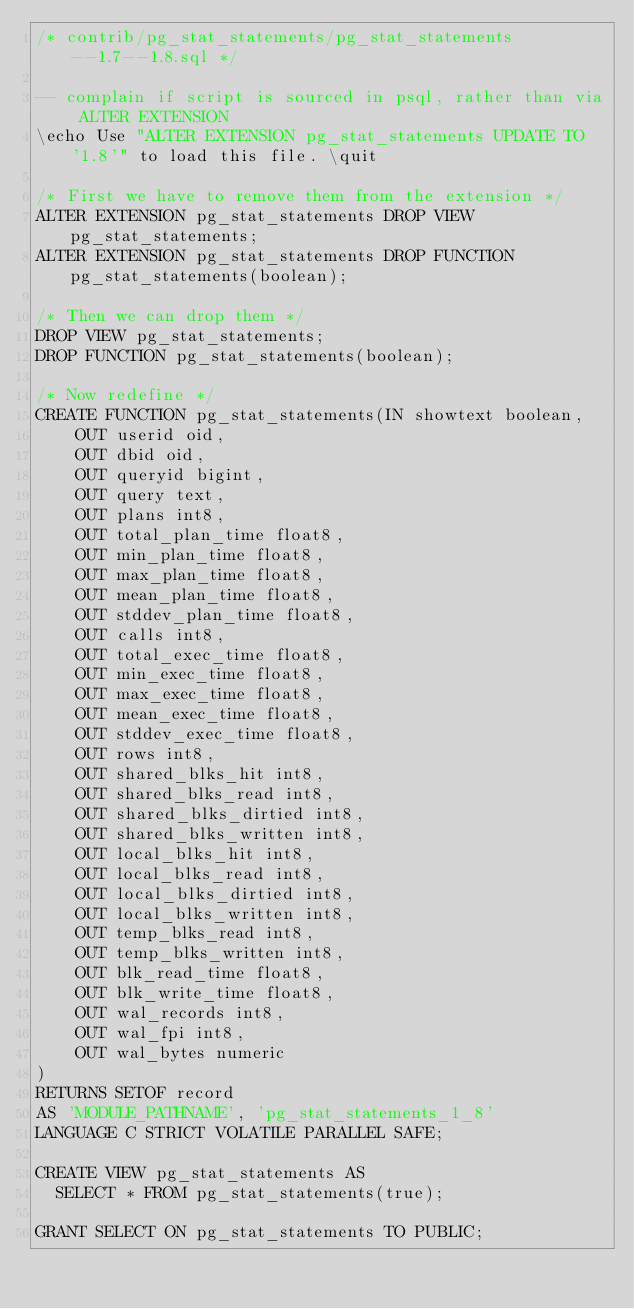Convert code to text. <code><loc_0><loc_0><loc_500><loc_500><_SQL_>/* contrib/pg_stat_statements/pg_stat_statements--1.7--1.8.sql */

-- complain if script is sourced in psql, rather than via ALTER EXTENSION
\echo Use "ALTER EXTENSION pg_stat_statements UPDATE TO '1.8'" to load this file. \quit

/* First we have to remove them from the extension */
ALTER EXTENSION pg_stat_statements DROP VIEW pg_stat_statements;
ALTER EXTENSION pg_stat_statements DROP FUNCTION pg_stat_statements(boolean);

/* Then we can drop them */
DROP VIEW pg_stat_statements;
DROP FUNCTION pg_stat_statements(boolean);

/* Now redefine */
CREATE FUNCTION pg_stat_statements(IN showtext boolean,
    OUT userid oid,
    OUT dbid oid,
    OUT queryid bigint,
    OUT query text,
    OUT plans int8,
    OUT total_plan_time float8,
    OUT min_plan_time float8,
    OUT max_plan_time float8,
    OUT mean_plan_time float8,
    OUT stddev_plan_time float8,
    OUT calls int8,
    OUT total_exec_time float8,
    OUT min_exec_time float8,
    OUT max_exec_time float8,
    OUT mean_exec_time float8,
    OUT stddev_exec_time float8,
    OUT rows int8,
    OUT shared_blks_hit int8,
    OUT shared_blks_read int8,
    OUT shared_blks_dirtied int8,
    OUT shared_blks_written int8,
    OUT local_blks_hit int8,
    OUT local_blks_read int8,
    OUT local_blks_dirtied int8,
    OUT local_blks_written int8,
    OUT temp_blks_read int8,
    OUT temp_blks_written int8,
    OUT blk_read_time float8,
    OUT blk_write_time float8,
    OUT wal_records int8,
    OUT wal_fpi int8,
    OUT wal_bytes numeric
)
RETURNS SETOF record
AS 'MODULE_PATHNAME', 'pg_stat_statements_1_8'
LANGUAGE C STRICT VOLATILE PARALLEL SAFE;

CREATE VIEW pg_stat_statements AS
  SELECT * FROM pg_stat_statements(true);

GRANT SELECT ON pg_stat_statements TO PUBLIC;
</code> 